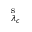<formula> <loc_0><loc_0><loc_500><loc_500>^ { s } _ { \lambda _ { c } }</formula> 